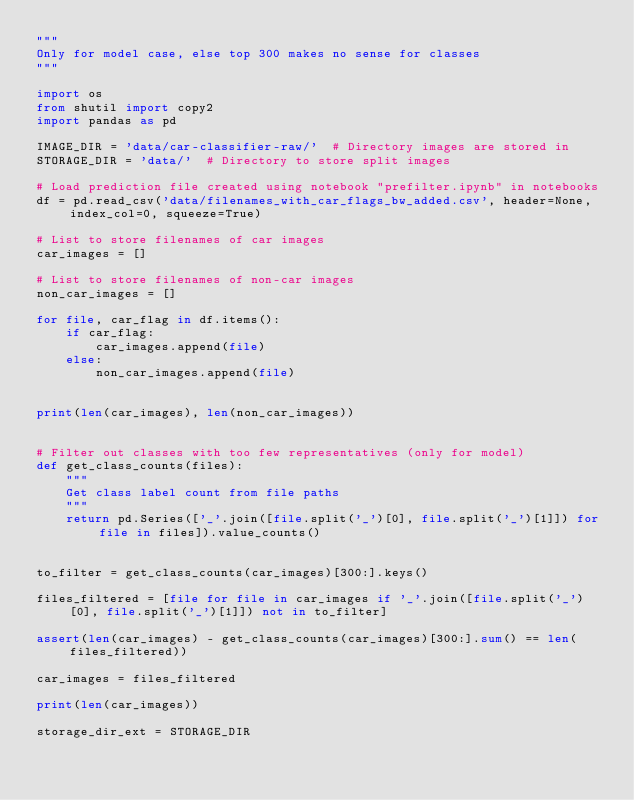Convert code to text. <code><loc_0><loc_0><loc_500><loc_500><_Python_>"""
Only for model case, else top 300 makes no sense for classes
"""

import os
from shutil import copy2
import pandas as pd

IMAGE_DIR = 'data/car-classifier-raw/'  # Directory images are stored in
STORAGE_DIR = 'data/'  # Directory to store split images

# Load prediction file created using notebook "prefilter.ipynb" in notebooks
df = pd.read_csv('data/filenames_with_car_flags_bw_added.csv', header=None, index_col=0, squeeze=True)

# List to store filenames of car images
car_images = []

# List to store filenames of non-car images
non_car_images = []

for file, car_flag in df.items():
    if car_flag:
        car_images.append(file)
    else:
        non_car_images.append(file)


print(len(car_images), len(non_car_images))


# Filter out classes with too few representatives (only for model)
def get_class_counts(files):
    """
    Get class label count from file paths
    """
    return pd.Series(['_'.join([file.split('_')[0], file.split('_')[1]]) for file in files]).value_counts()


to_filter = get_class_counts(car_images)[300:].keys()

files_filtered = [file for file in car_images if '_'.join([file.split('_')[0], file.split('_')[1]]) not in to_filter]

assert(len(car_images) - get_class_counts(car_images)[300:].sum() == len(files_filtered))

car_images = files_filtered

print(len(car_images))

storage_dir_ext = STORAGE_DIR
</code> 